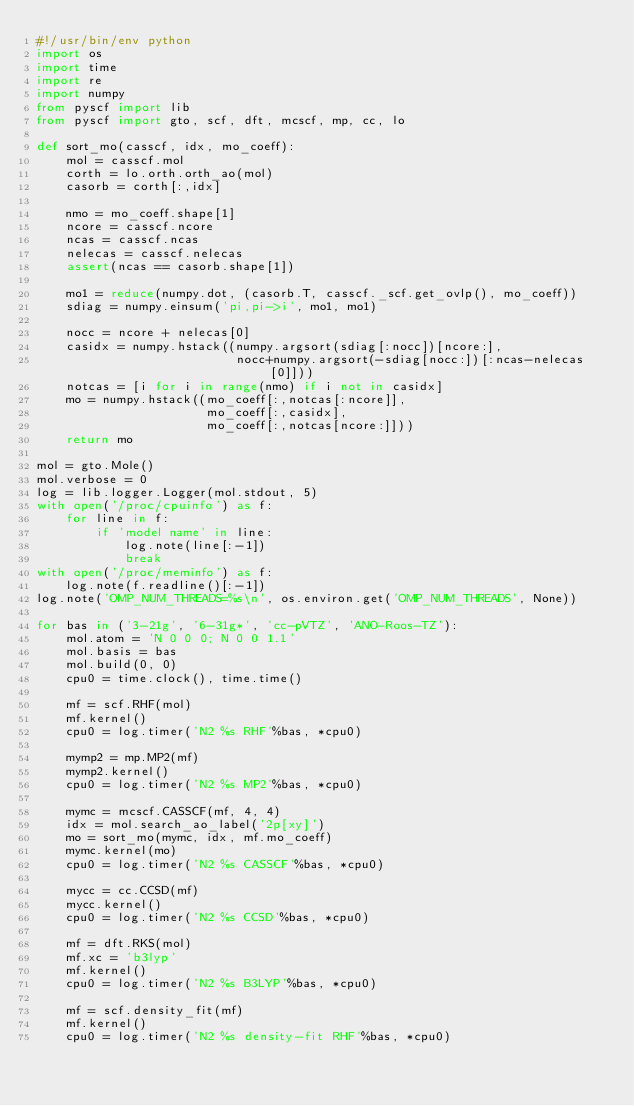<code> <loc_0><loc_0><loc_500><loc_500><_Python_>#!/usr/bin/env python
import os
import time
import re
import numpy
from pyscf import lib
from pyscf import gto, scf, dft, mcscf, mp, cc, lo

def sort_mo(casscf, idx, mo_coeff):
    mol = casscf.mol
    corth = lo.orth.orth_ao(mol)
    casorb = corth[:,idx]

    nmo = mo_coeff.shape[1]
    ncore = casscf.ncore
    ncas = casscf.ncas
    nelecas = casscf.nelecas
    assert(ncas == casorb.shape[1])

    mo1 = reduce(numpy.dot, (casorb.T, casscf._scf.get_ovlp(), mo_coeff))
    sdiag = numpy.einsum('pi,pi->i', mo1, mo1)

    nocc = ncore + nelecas[0]
    casidx = numpy.hstack((numpy.argsort(sdiag[:nocc])[ncore:],
                           nocc+numpy.argsort(-sdiag[nocc:])[:ncas-nelecas[0]]))
    notcas = [i for i in range(nmo) if i not in casidx]
    mo = numpy.hstack((mo_coeff[:,notcas[:ncore]],
                       mo_coeff[:,casidx],
                       mo_coeff[:,notcas[ncore:]]))
    return mo

mol = gto.Mole()
mol.verbose = 0
log = lib.logger.Logger(mol.stdout, 5)
with open('/proc/cpuinfo') as f:
    for line in f:
        if 'model name' in line:
            log.note(line[:-1])
            break
with open('/proc/meminfo') as f:
    log.note(f.readline()[:-1])
log.note('OMP_NUM_THREADS=%s\n', os.environ.get('OMP_NUM_THREADS', None))

for bas in ('3-21g', '6-31g*', 'cc-pVTZ', 'ANO-Roos-TZ'):
    mol.atom = 'N 0 0 0; N 0 0 1.1'
    mol.basis = bas
    mol.build(0, 0)
    cpu0 = time.clock(), time.time()

    mf = scf.RHF(mol)
    mf.kernel()
    cpu0 = log.timer('N2 %s RHF'%bas, *cpu0)

    mymp2 = mp.MP2(mf)
    mymp2.kernel()
    cpu0 = log.timer('N2 %s MP2'%bas, *cpu0)

    mymc = mcscf.CASSCF(mf, 4, 4)
    idx = mol.search_ao_label('2p[xy]')
    mo = sort_mo(mymc, idx, mf.mo_coeff)
    mymc.kernel(mo)
    cpu0 = log.timer('N2 %s CASSCF'%bas, *cpu0)

    mycc = cc.CCSD(mf)
    mycc.kernel()
    cpu0 = log.timer('N2 %s CCSD'%bas, *cpu0)

    mf = dft.RKS(mol)
    mf.xc = 'b3lyp'
    mf.kernel()
    cpu0 = log.timer('N2 %s B3LYP'%bas, *cpu0)

    mf = scf.density_fit(mf)
    mf.kernel()
    cpu0 = log.timer('N2 %s density-fit RHF'%bas, *cpu0)
</code> 